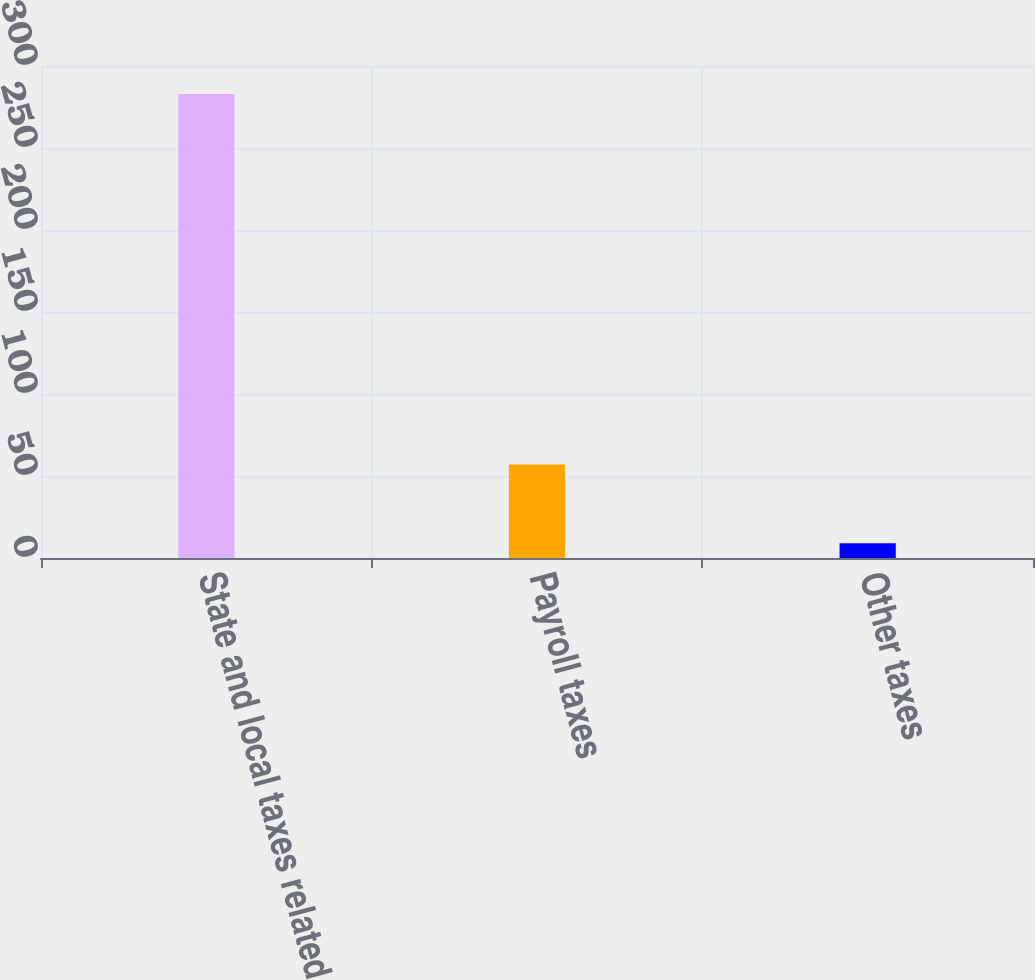Convert chart to OTSL. <chart><loc_0><loc_0><loc_500><loc_500><bar_chart><fcel>State and local taxes related<fcel>Payroll taxes<fcel>Other taxes<nl><fcel>283<fcel>57<fcel>9<nl></chart> 